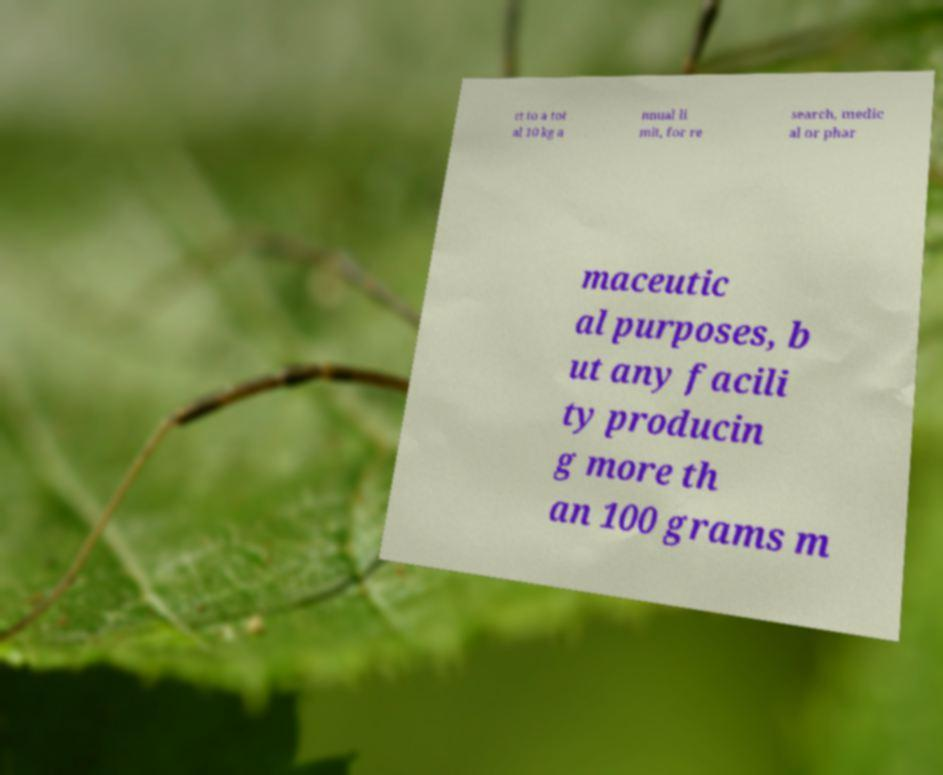Please read and relay the text visible in this image. What does it say? ct to a tot al 10 kg a nnual li mit, for re search, medic al or phar maceutic al purposes, b ut any facili ty producin g more th an 100 grams m 